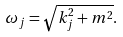Convert formula to latex. <formula><loc_0><loc_0><loc_500><loc_500>\omega _ { j } = \sqrt { k _ { j } ^ { 2 } + m ^ { 2 } } .</formula> 